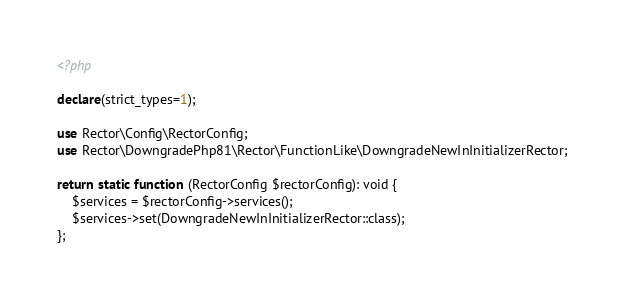<code> <loc_0><loc_0><loc_500><loc_500><_PHP_><?php

declare(strict_types=1);

use Rector\Config\RectorConfig;
use Rector\DowngradePhp81\Rector\FunctionLike\DowngradeNewInInitializerRector;

return static function (RectorConfig $rectorConfig): void {
    $services = $rectorConfig->services();
    $services->set(DowngradeNewInInitializerRector::class);
};
</code> 